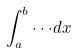<formula> <loc_0><loc_0><loc_500><loc_500>\int _ { a } ^ { b } \cdot \cdot \cdot d x</formula> 